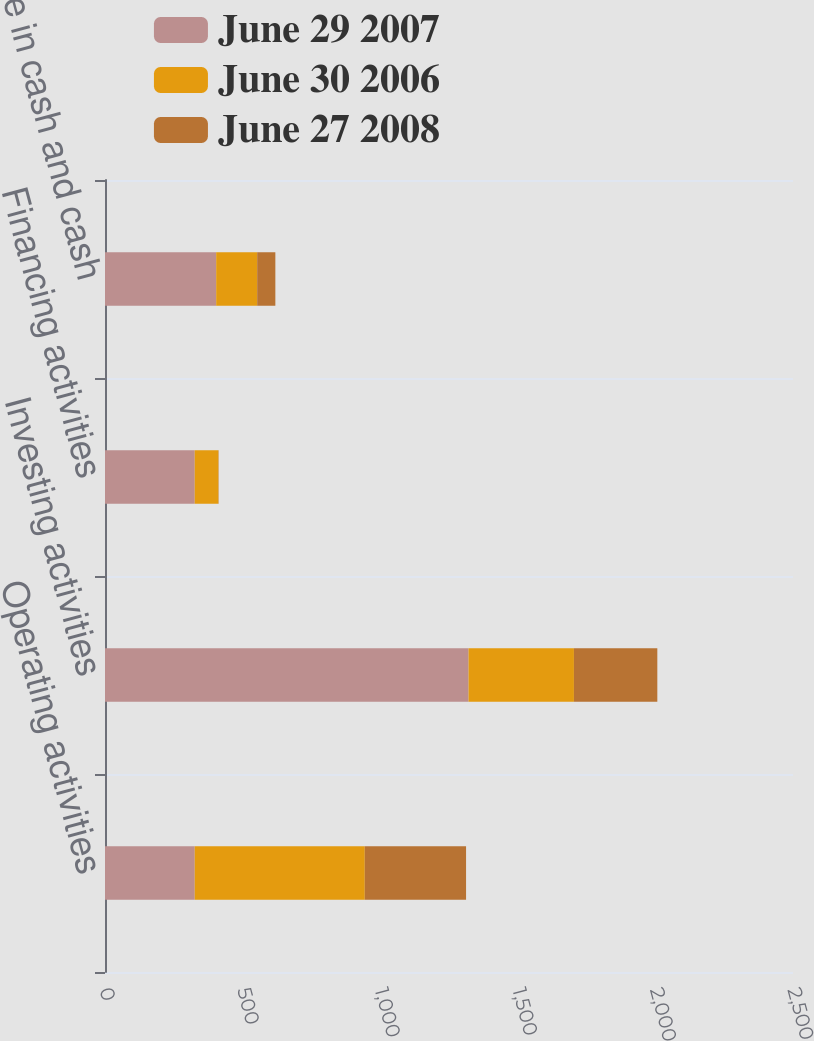<chart> <loc_0><loc_0><loc_500><loc_500><stacked_bar_chart><ecel><fcel>Operating activities<fcel>Investing activities<fcel>Financing activities<fcel>Net increase in cash and cash<nl><fcel>June 29 2007<fcel>326<fcel>1321<fcel>326<fcel>404<nl><fcel>June 30 2006<fcel>618<fcel>383<fcel>86<fcel>149<nl><fcel>June 27 2008<fcel>368<fcel>303<fcel>1<fcel>66<nl></chart> 